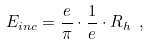Convert formula to latex. <formula><loc_0><loc_0><loc_500><loc_500>E _ { i n c } = \frac { e } { \pi } \cdot \frac { 1 } { e } \cdot R _ { h } \ ,</formula> 